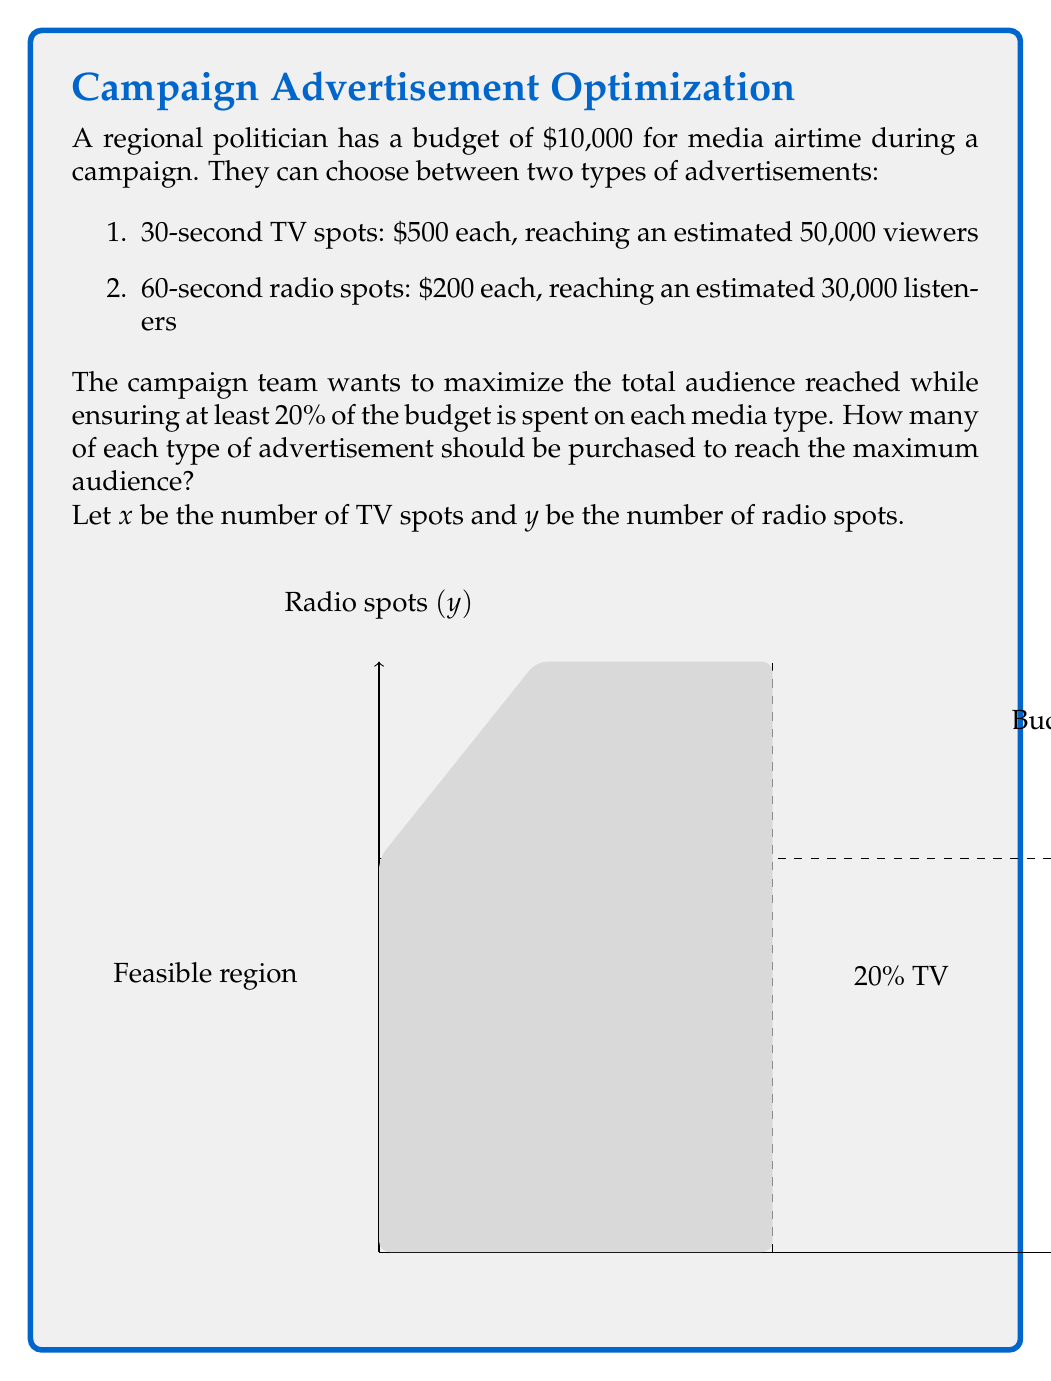Provide a solution to this math problem. Let's approach this step-by-step:

1) First, we need to set up our objective function. We want to maximize the total audience reached:

   $\text{Maximize } f(x,y) = 50000x + 30000y$

2) Now, let's define our constraints:

   a) Budget constraint: $500x + 200y \leq 10000$
   b) At least 20% on TV: $500x \geq 0.2(10000) = 2000$, or $x \geq 4$
   c) At least 20% on radio: $200y \geq 0.2(10000) = 2000$, or $y \geq 10$
   d) Non-negativity: $x \geq 0$, $y \geq 0$

3) We can simplify the budget constraint:

   $500x + 200y \leq 10000$
   $5x + 2y \leq 100$

4) This is a linear programming problem. The optimal solution will be at one of the corner points of the feasible region.

5) The corner points are:
   - (4, 10)
   - (4, 40)
   - (16, 10)

6) Let's evaluate our objective function at each point:

   $f(4, 10) = 50000(4) + 30000(10) = 500000$
   $f(4, 40) = 50000(4) + 30000(40) = 1400000$
   $f(16, 10) = 50000(16) + 30000(10) = 1100000$

7) The maximum value is achieved at the point (4, 40).

Therefore, the optimal solution is to purchase 4 TV spots and 40 radio spots.
Answer: 4 TV spots, 40 radio spots 